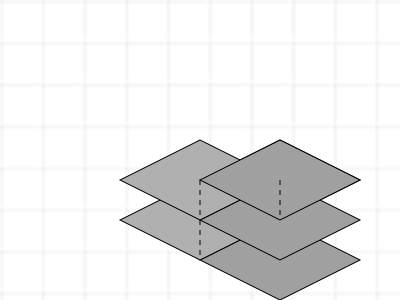As a post-doctoral researcher with experience in data-intensive projects, analyze the given isometric view of a 3D structure. How many individual cubes are present in this structure? To determine the number of cubes in this 3D structure, we'll analyze it layer by layer:

1. Bottom layer:
   - Full visibility of a $3 \times 3$ grid = 9 cubes

2. Middle layer:
   - Visible cubes: 2 x 2 = 4 cubes
   - Hidden cube (inferred from structure): 1 cube
   - Total in middle layer: 4 + 1 = 5 cubes

3. Top layer:
   - Clearly visible: 1 cube

Now, let's sum up the cubes from all layers:
$$ \text{Total cubes} = \text{Bottom layer} + \text{Middle layer} + \text{Top layer} $$
$$ \text{Total cubes} = 9 + 5 + 1 = 15 $$

Therefore, the 3D structure consists of 15 individual cubes.
Answer: 15 cubes 